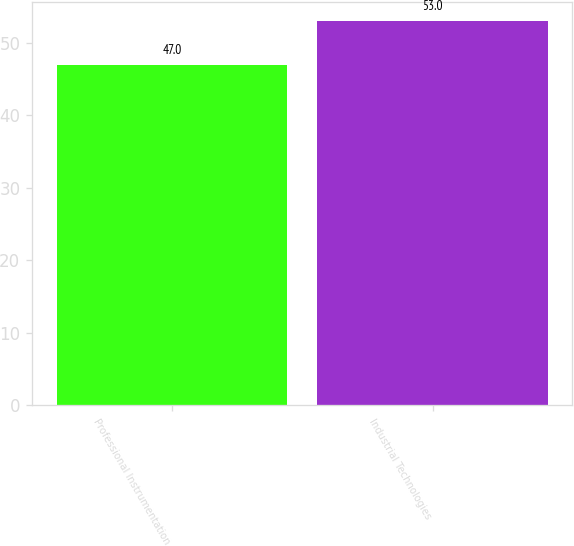Convert chart. <chart><loc_0><loc_0><loc_500><loc_500><bar_chart><fcel>Professional Instrumentation<fcel>Industrial Technologies<nl><fcel>47<fcel>53<nl></chart> 